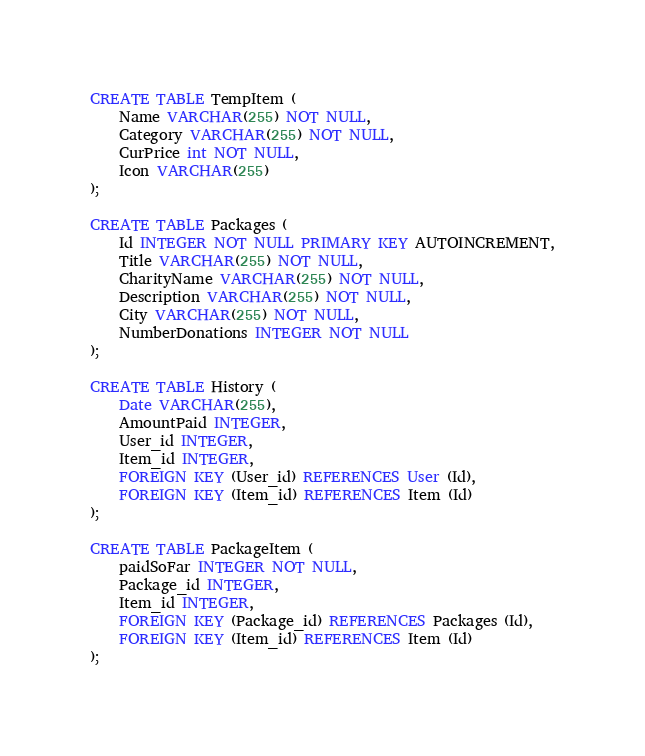<code> <loc_0><loc_0><loc_500><loc_500><_SQL_>
CREATE TABLE TempItem (
    Name VARCHAR(255) NOT NULL,
    Category VARCHAR(255) NOT NULL,
    CurPrice int NOT NULL, 
    Icon VARCHAR(255)
);

CREATE TABLE Packages (
    Id INTEGER NOT NULL PRIMARY KEY AUTOINCREMENT,
    Title VARCHAR(255) NOT NULL,
    CharityName VARCHAR(255) NOT NULL,
    Description VARCHAR(255) NOT NULL,
    City VARCHAR(255) NOT NULL,
    NumberDonations INTEGER NOT NULL
);

CREATE TABLE History (
    Date VARCHAR(255),
    AmountPaid INTEGER,
    User_id INTEGER,
    Item_id INTEGER,
    FOREIGN KEY (User_id) REFERENCES User (Id),
    FOREIGN KEY (Item_id) REFERENCES Item (Id)
);

CREATE TABLE PackageItem (
    paidSoFar INTEGER NOT NULL,
    Package_id INTEGER,
    Item_id INTEGER,
    FOREIGN KEY (Package_id) REFERENCES Packages (Id),
    FOREIGN KEY (Item_id) REFERENCES Item (Id)
);</code> 